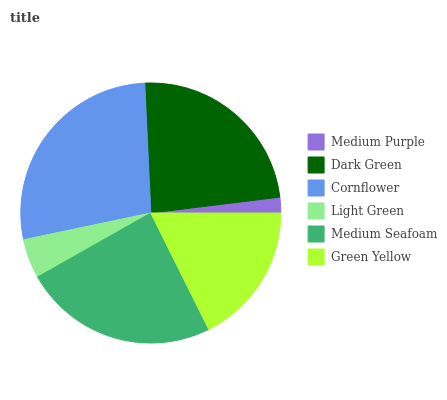Is Medium Purple the minimum?
Answer yes or no. Yes. Is Cornflower the maximum?
Answer yes or no. Yes. Is Dark Green the minimum?
Answer yes or no. No. Is Dark Green the maximum?
Answer yes or no. No. Is Dark Green greater than Medium Purple?
Answer yes or no. Yes. Is Medium Purple less than Dark Green?
Answer yes or no. Yes. Is Medium Purple greater than Dark Green?
Answer yes or no. No. Is Dark Green less than Medium Purple?
Answer yes or no. No. Is Dark Green the high median?
Answer yes or no. Yes. Is Green Yellow the low median?
Answer yes or no. Yes. Is Medium Seafoam the high median?
Answer yes or no. No. Is Dark Green the low median?
Answer yes or no. No. 